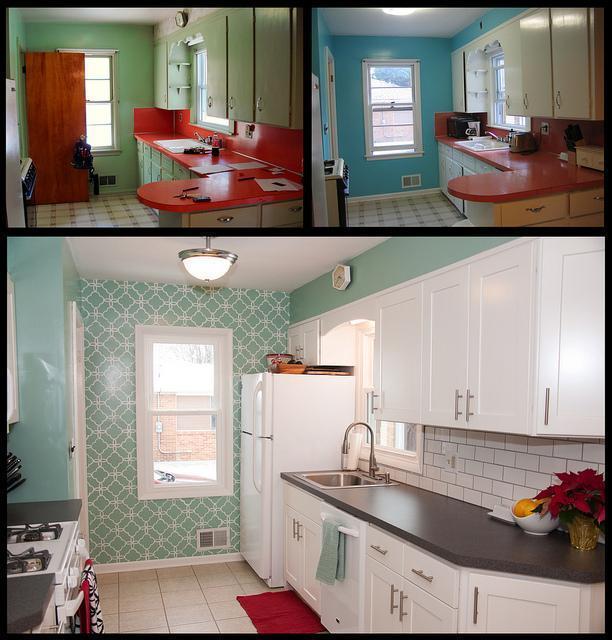How many scenes are pictures here?
Give a very brief answer. 3. How many refrigerators are in the picture?
Give a very brief answer. 2. How many men are wearing a head scarf?
Give a very brief answer. 0. 